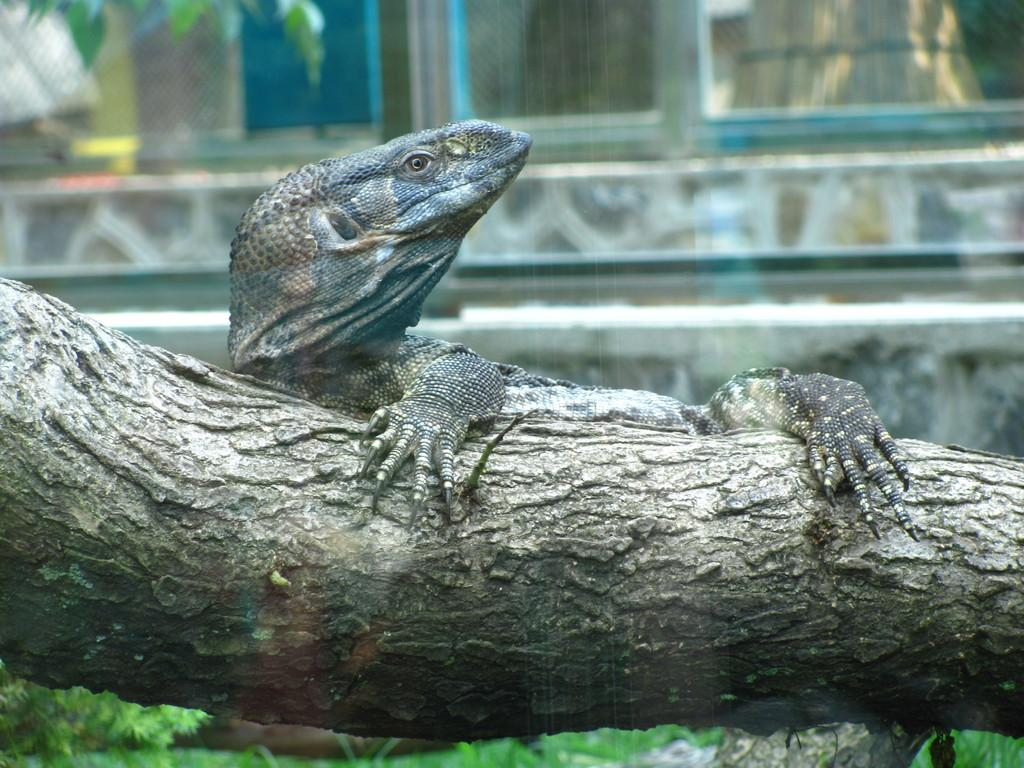What type of animal can be seen in the image? There is a reptile in the image. Where is the reptile located? The reptile is on a branch of a tree. What can be seen on the ground in the image? There is grass visible on the ground in the image. How many eggs are being used to make the cream in the image? There is no cream or eggs present in the image; it features a reptile on a tree branch with grass visible on the ground. 